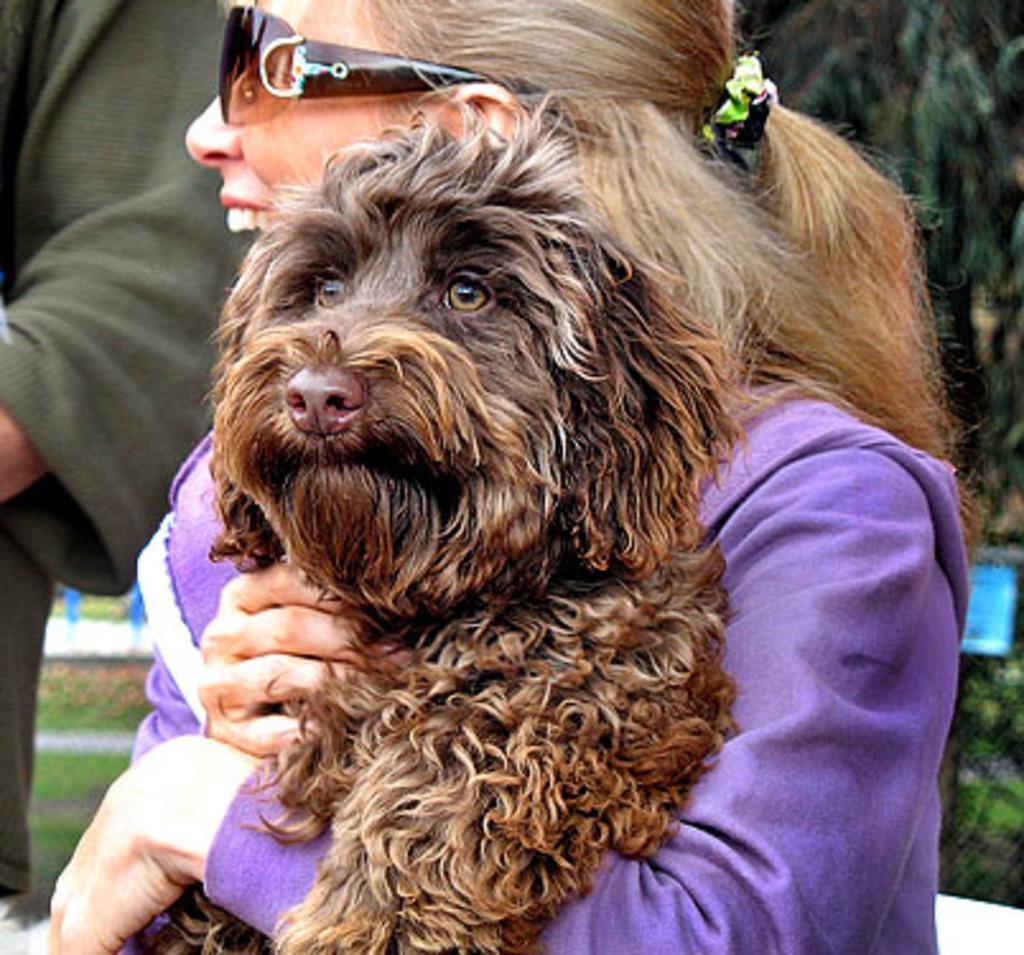How would you summarize this image in a sentence or two? In this image there is a lady person wearing violet color dress holding dog in her hands. 